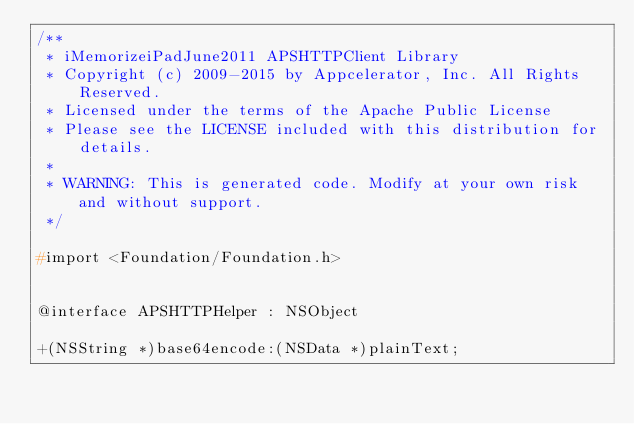Convert code to text. <code><loc_0><loc_0><loc_500><loc_500><_C_>/**
 * iMemorizeiPadJune2011 APSHTTPClient Library
 * Copyright (c) 2009-2015 by Appcelerator, Inc. All Rights Reserved.
 * Licensed under the terms of the Apache Public License
 * Please see the LICENSE included with this distribution for details.
 * 
 * WARNING: This is generated code. Modify at your own risk and without support.
 */

#import <Foundation/Foundation.h>


@interface APSHTTPHelper : NSObject

+(NSString *)base64encode:(NSData *)plainText;</code> 